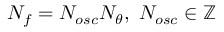Convert formula to latex. <formula><loc_0><loc_0><loc_500><loc_500>N _ { f } = N _ { o s c } N _ { \theta } , \ N _ { o s c } \in \mathbb { Z }</formula> 